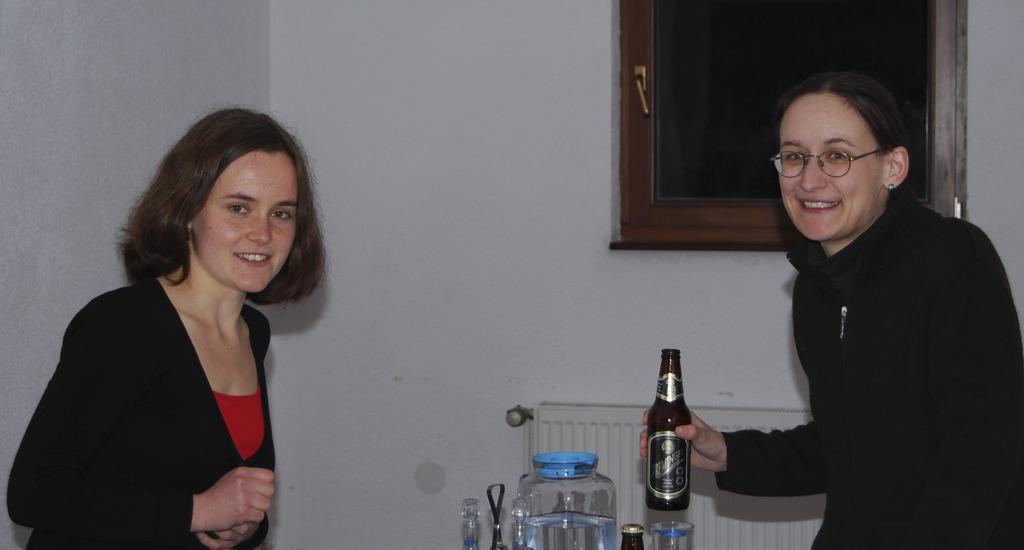How would you summarize this image in a sentence or two? This two womens are standing. This woman holds bottle and smile. We can able to see jar, bottle and glass. This is window with door. These two women wore black jacket. 